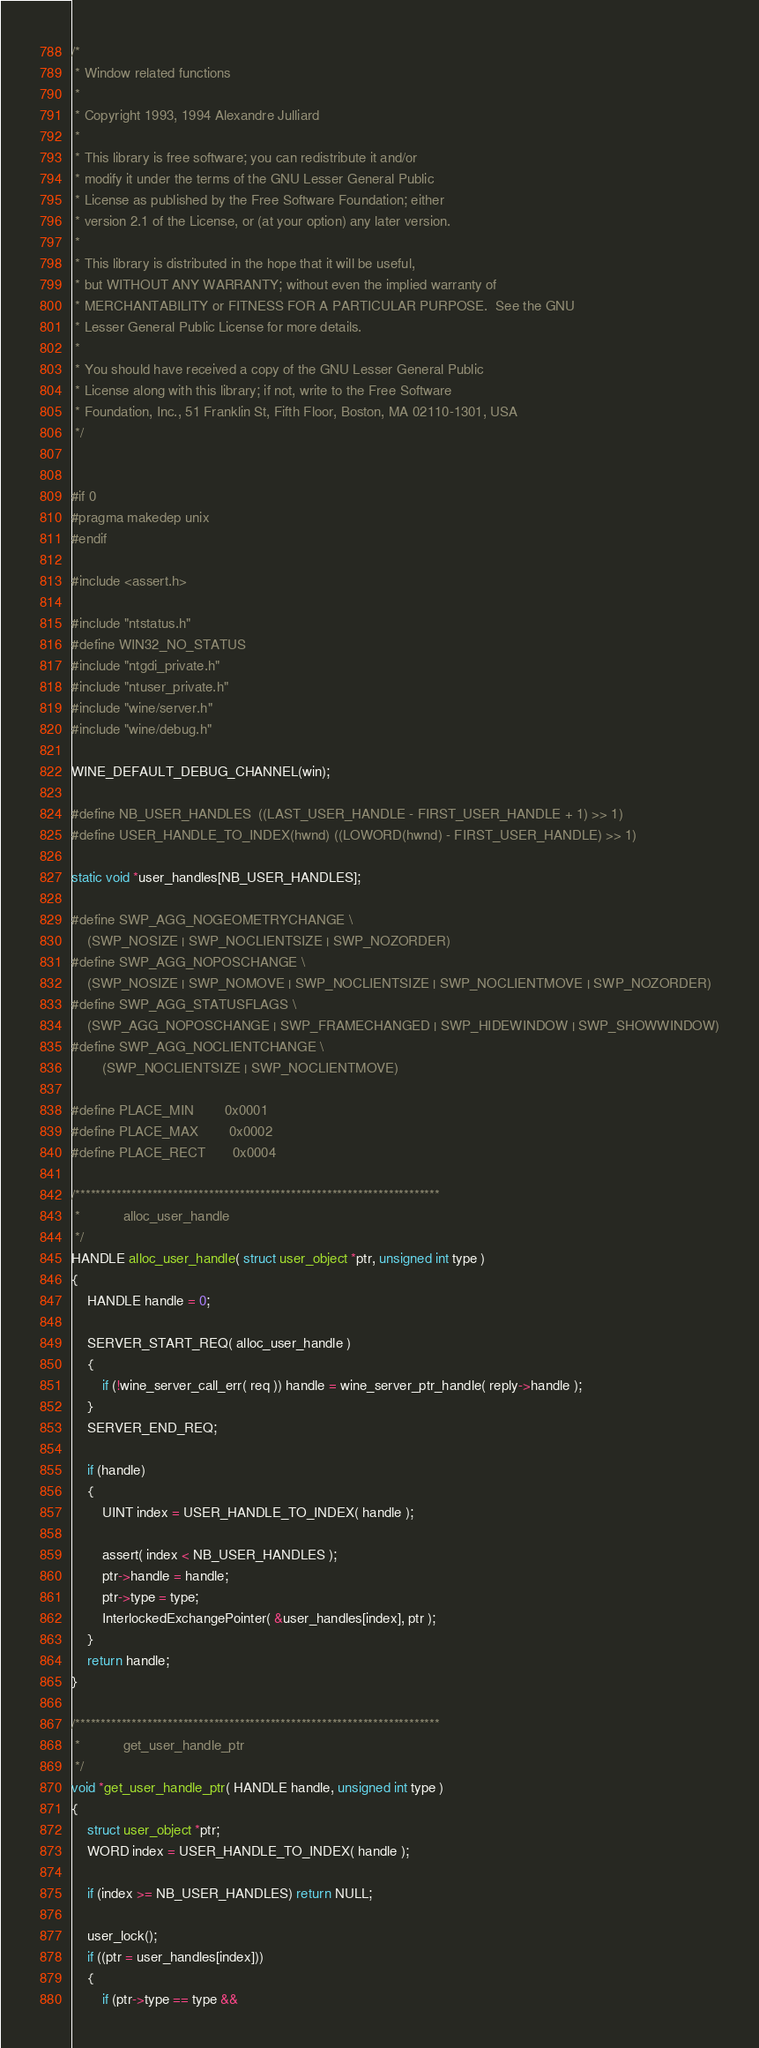<code> <loc_0><loc_0><loc_500><loc_500><_C_>/*
 * Window related functions
 *
 * Copyright 1993, 1994 Alexandre Julliard
 *
 * This library is free software; you can redistribute it and/or
 * modify it under the terms of the GNU Lesser General Public
 * License as published by the Free Software Foundation; either
 * version 2.1 of the License, or (at your option) any later version.
 *
 * This library is distributed in the hope that it will be useful,
 * but WITHOUT ANY WARRANTY; without even the implied warranty of
 * MERCHANTABILITY or FITNESS FOR A PARTICULAR PURPOSE.  See the GNU
 * Lesser General Public License for more details.
 *
 * You should have received a copy of the GNU Lesser General Public
 * License along with this library; if not, write to the Free Software
 * Foundation, Inc., 51 Franklin St, Fifth Floor, Boston, MA 02110-1301, USA
 */


#if 0
#pragma makedep unix
#endif

#include <assert.h>

#include "ntstatus.h"
#define WIN32_NO_STATUS
#include "ntgdi_private.h"
#include "ntuser_private.h"
#include "wine/server.h"
#include "wine/debug.h"

WINE_DEFAULT_DEBUG_CHANNEL(win);

#define NB_USER_HANDLES  ((LAST_USER_HANDLE - FIRST_USER_HANDLE + 1) >> 1)
#define USER_HANDLE_TO_INDEX(hwnd) ((LOWORD(hwnd) - FIRST_USER_HANDLE) >> 1)

static void *user_handles[NB_USER_HANDLES];

#define SWP_AGG_NOGEOMETRYCHANGE \
    (SWP_NOSIZE | SWP_NOCLIENTSIZE | SWP_NOZORDER)
#define SWP_AGG_NOPOSCHANGE \
    (SWP_NOSIZE | SWP_NOMOVE | SWP_NOCLIENTSIZE | SWP_NOCLIENTMOVE | SWP_NOZORDER)
#define SWP_AGG_STATUSFLAGS \
    (SWP_AGG_NOPOSCHANGE | SWP_FRAMECHANGED | SWP_HIDEWINDOW | SWP_SHOWWINDOW)
#define SWP_AGG_NOCLIENTCHANGE \
        (SWP_NOCLIENTSIZE | SWP_NOCLIENTMOVE)

#define PLACE_MIN		0x0001
#define PLACE_MAX		0x0002
#define PLACE_RECT		0x0004

/***********************************************************************
 *           alloc_user_handle
 */
HANDLE alloc_user_handle( struct user_object *ptr, unsigned int type )
{
    HANDLE handle = 0;

    SERVER_START_REQ( alloc_user_handle )
    {
        if (!wine_server_call_err( req )) handle = wine_server_ptr_handle( reply->handle );
    }
    SERVER_END_REQ;

    if (handle)
    {
        UINT index = USER_HANDLE_TO_INDEX( handle );

        assert( index < NB_USER_HANDLES );
        ptr->handle = handle;
        ptr->type = type;
        InterlockedExchangePointer( &user_handles[index], ptr );
    }
    return handle;
}

/***********************************************************************
 *           get_user_handle_ptr
 */
void *get_user_handle_ptr( HANDLE handle, unsigned int type )
{
    struct user_object *ptr;
    WORD index = USER_HANDLE_TO_INDEX( handle );

    if (index >= NB_USER_HANDLES) return NULL;

    user_lock();
    if ((ptr = user_handles[index]))
    {
        if (ptr->type == type &&</code> 